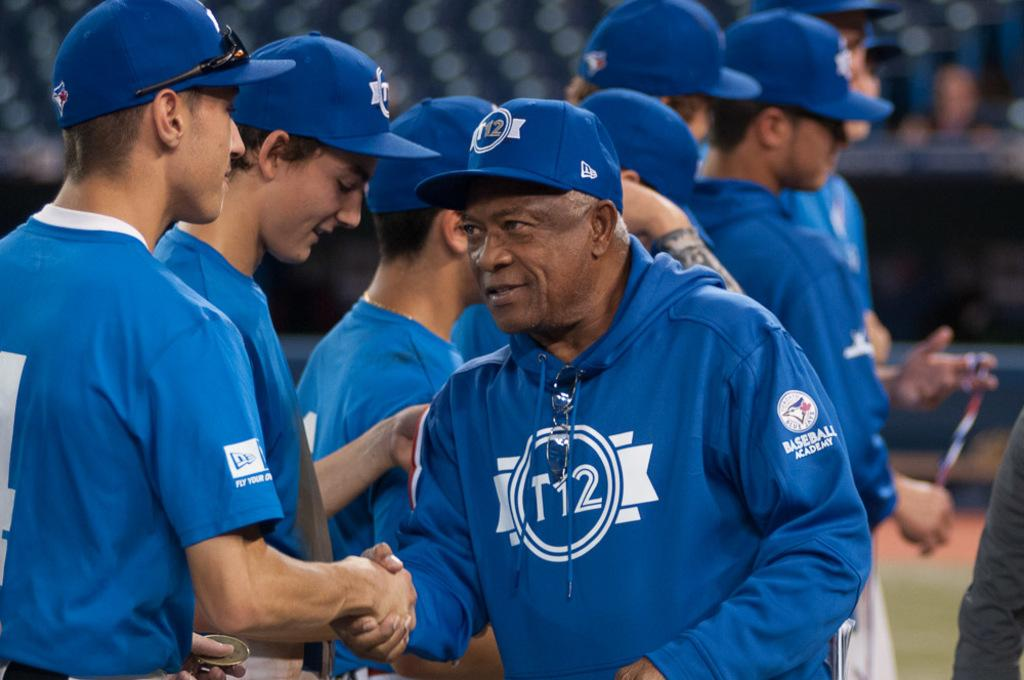<image>
Present a compact description of the photo's key features. T12 can be seen on a blue sweatshirt a man is wearing while shaking hands. 